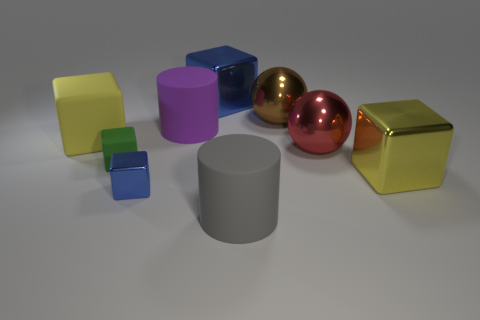The other cylinder that is the same size as the purple matte cylinder is what color?
Offer a terse response. Gray. Are there an equal number of blue shiny objects behind the tiny rubber cube and gray cylinders?
Your answer should be very brief. Yes. There is a thing that is both on the right side of the small green rubber object and left of the large purple matte cylinder; what shape is it?
Ensure brevity in your answer.  Cube. Does the purple cylinder have the same size as the green matte block?
Your answer should be very brief. No. Is there a red object that has the same material as the large gray cylinder?
Give a very brief answer. No. The other block that is the same color as the small metallic block is what size?
Ensure brevity in your answer.  Large. What number of large metallic objects are right of the gray cylinder and behind the small rubber block?
Your response must be concise. 2. What is the large sphere left of the big red metal sphere made of?
Give a very brief answer. Metal. What number of cylinders are the same color as the tiny matte block?
Your answer should be very brief. 0. There is a gray thing that is the same material as the large purple thing; what is its size?
Keep it short and to the point. Large. 